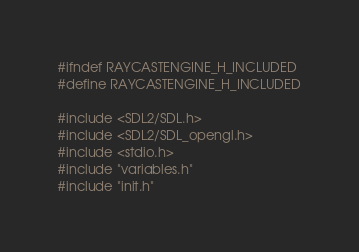<code> <loc_0><loc_0><loc_500><loc_500><_C_>#ifndef RAYCASTENGINE_H_INCLUDED
#define RAYCASTENGINE_H_INCLUDED

#include <SDL2/SDL.h>
#include <SDL2/SDL_opengl.h>
#include <stdio.h>
#include "variables.h"
#include "init.h"</code> 